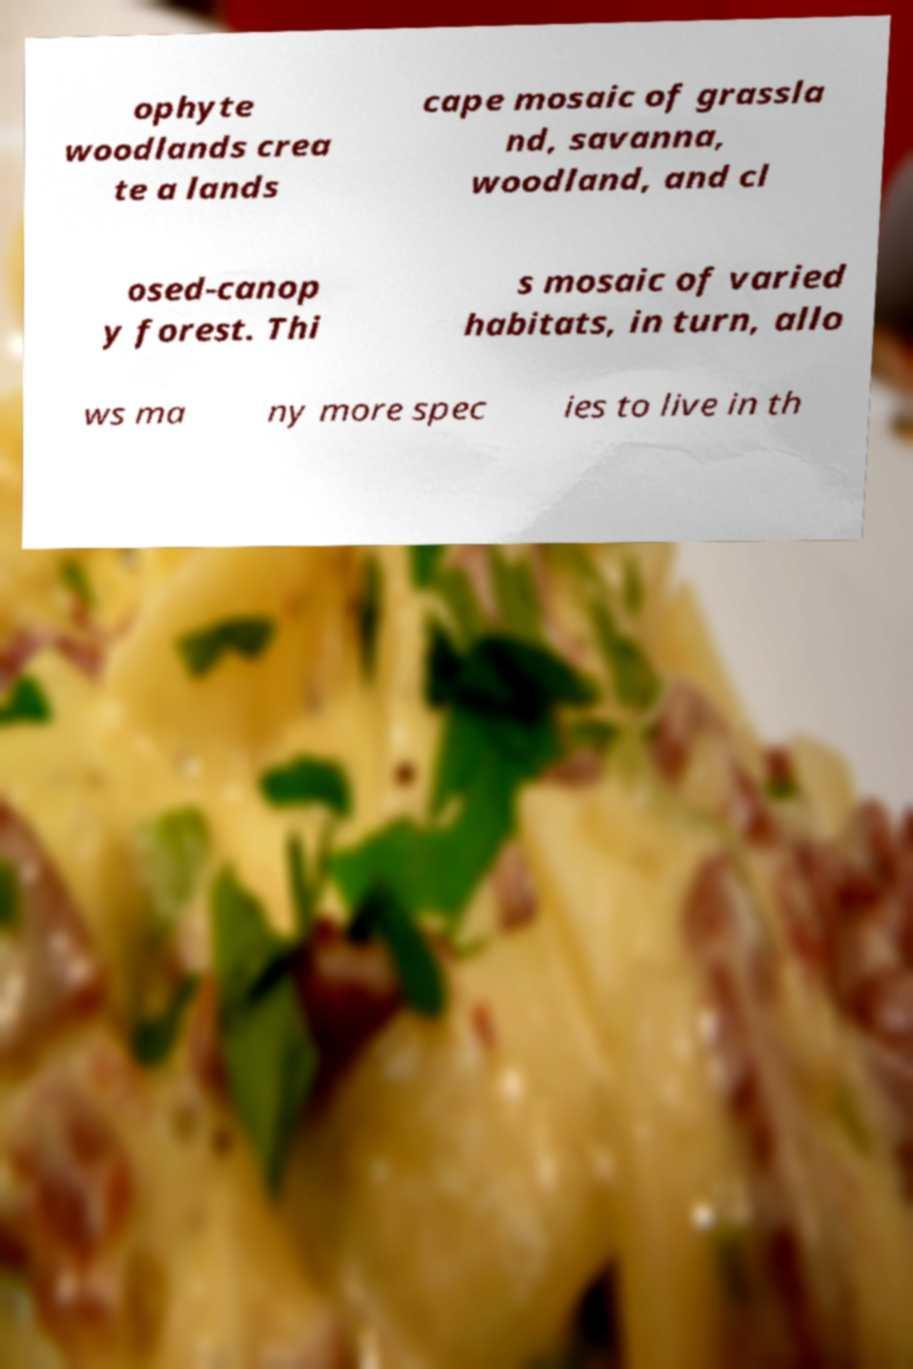What messages or text are displayed in this image? I need them in a readable, typed format. ophyte woodlands crea te a lands cape mosaic of grassla nd, savanna, woodland, and cl osed-canop y forest. Thi s mosaic of varied habitats, in turn, allo ws ma ny more spec ies to live in th 